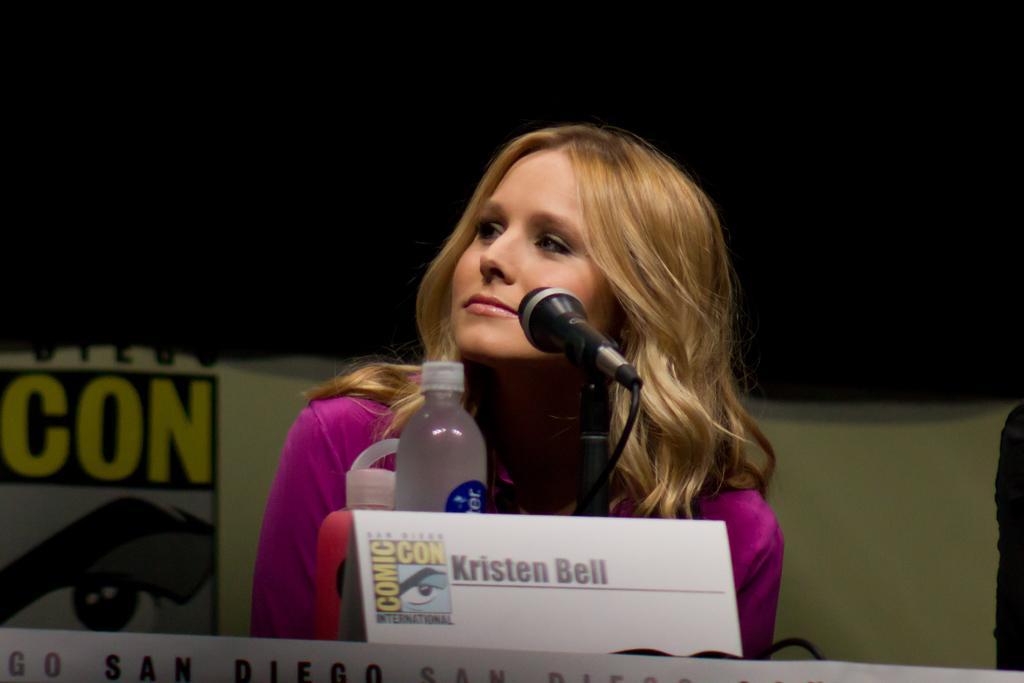How would you summarize this image in a sentence or two? In this image in the center is one woman who is sitting and in front of her there is one mike, bottle and some board. On the board there is some text and in the background there is a wall, on the wall there is some text. 